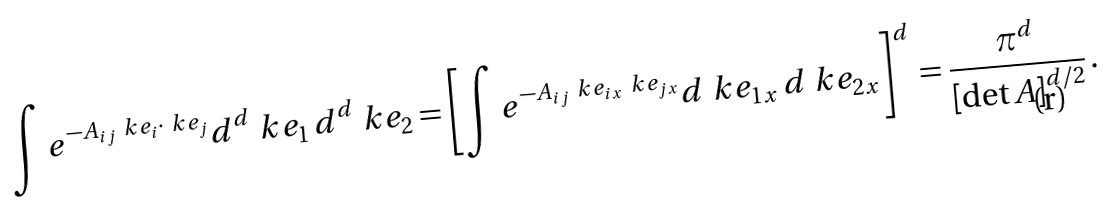<formula> <loc_0><loc_0><loc_500><loc_500>\int e ^ { - A _ { i j } \ k e _ { i } \cdot \ k e _ { j } } d ^ { d } \ k e _ { 1 } \, d ^ { d } \ k e _ { 2 } = \left [ \int e ^ { - A _ { i j } \ k e _ { i x } \ k e _ { j x } } d \ k e _ { 1 x } \, d \ k e _ { 2 x } \right ] ^ { d } = \frac { \pi ^ { d } } { \left [ \det A \right ] ^ { d / 2 } } \, .</formula> 